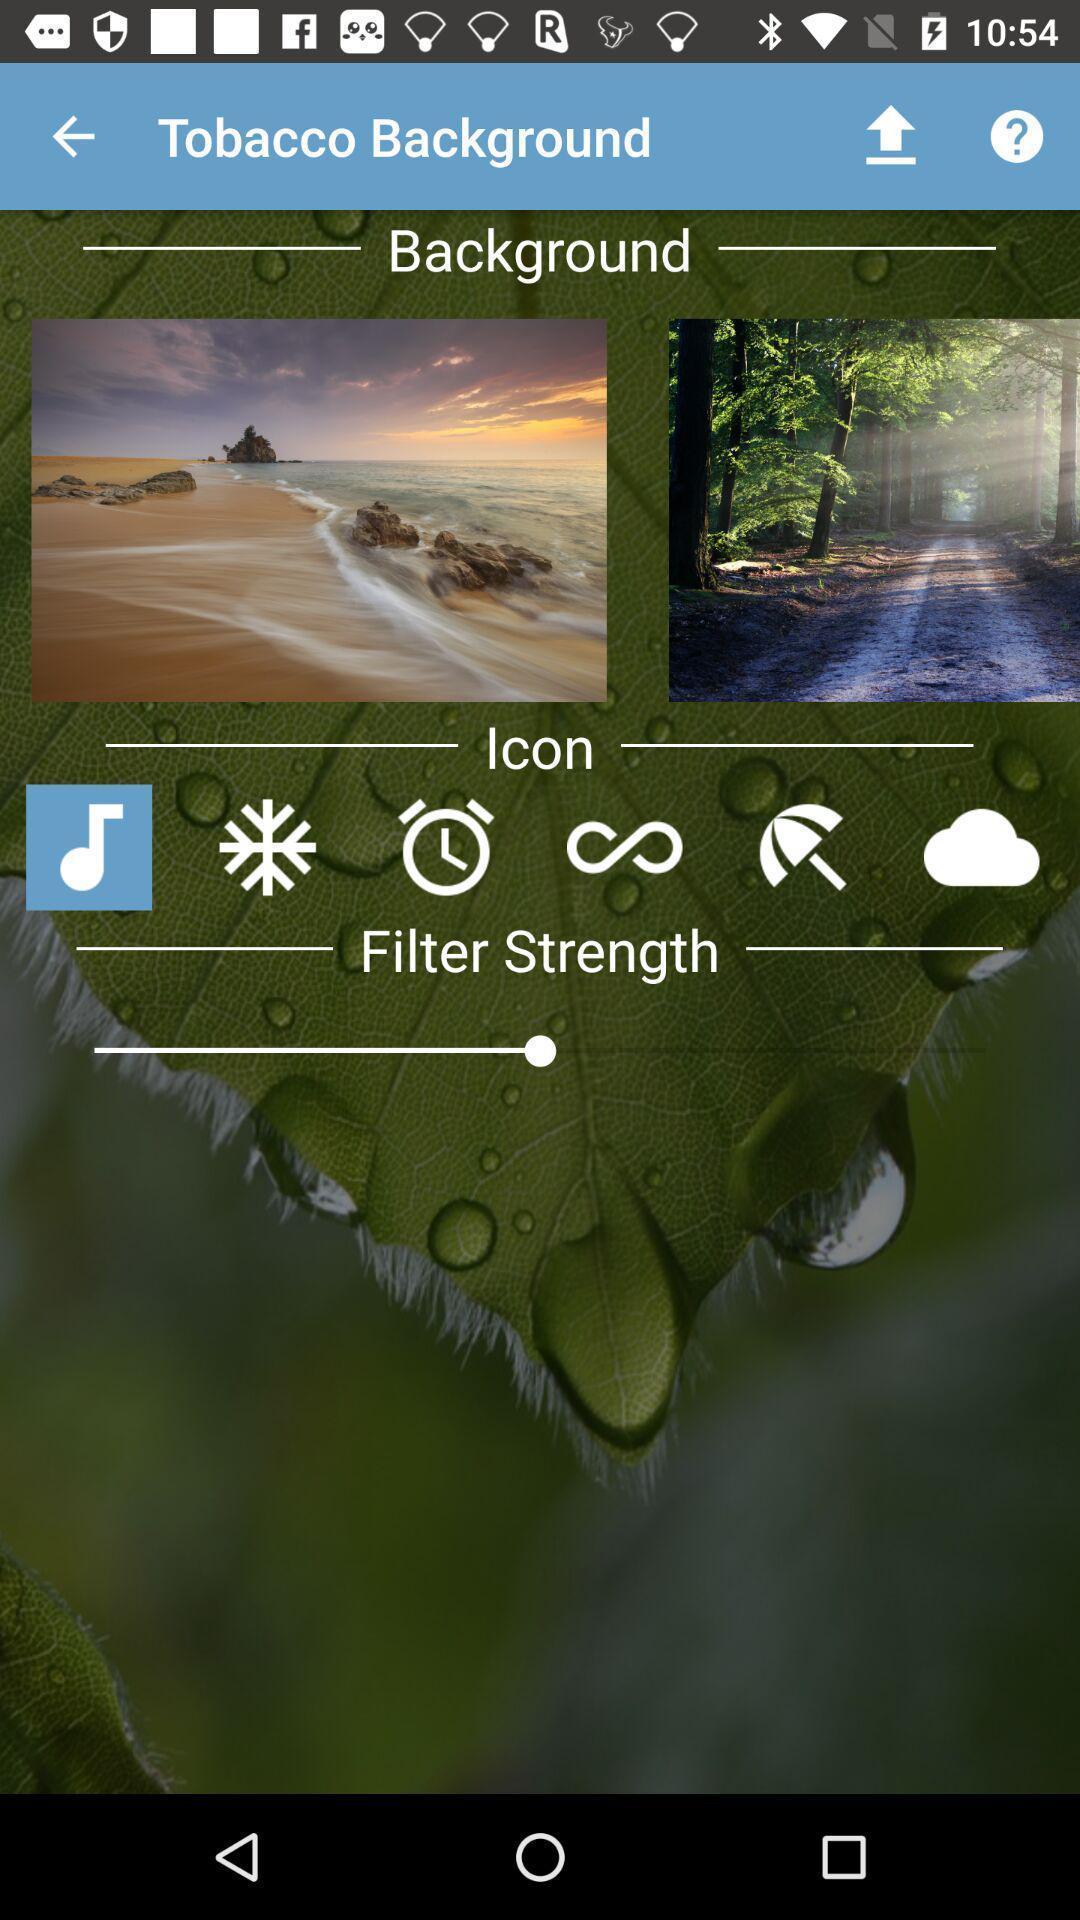Summarize the information in this screenshot. Wallpapers showing in this page. 